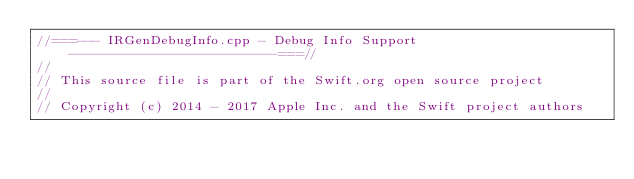Convert code to text. <code><loc_0><loc_0><loc_500><loc_500><_C++_>//===--- IRGenDebugInfo.cpp - Debug Info Support --------------------------===//
//
// This source file is part of the Swift.org open source project
//
// Copyright (c) 2014 - 2017 Apple Inc. and the Swift project authors</code> 